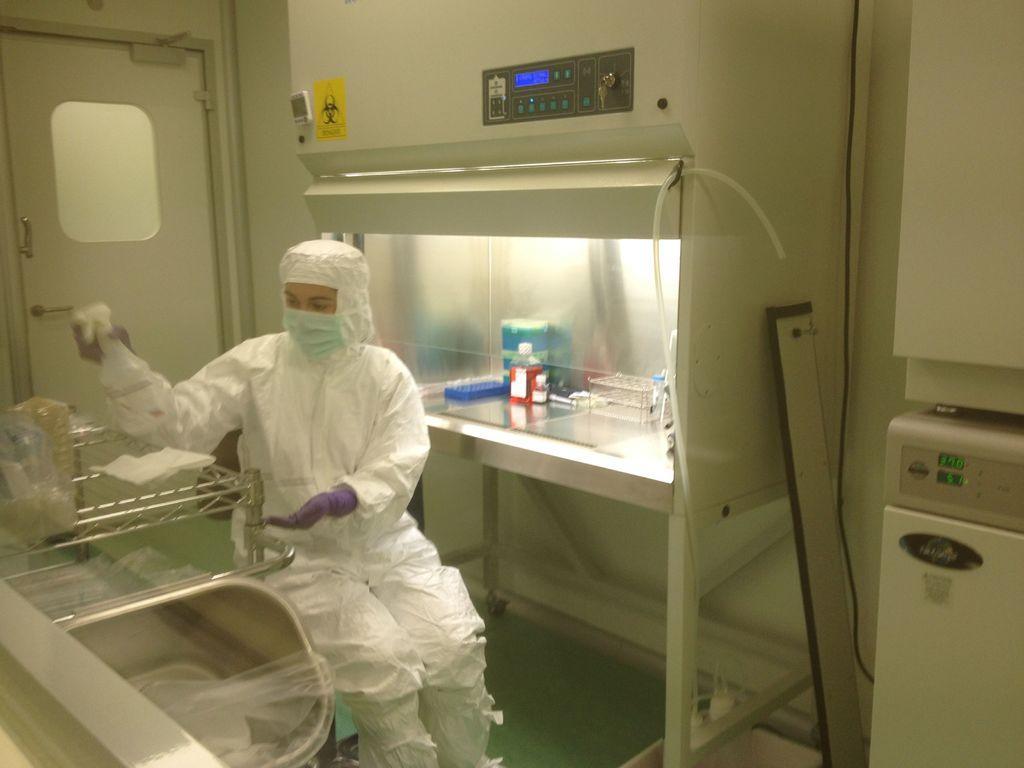Can you describe this image briefly? In this image there is one person who is wearing a mask, and the person is holding some bottle and spraying. In font of the person there are some plastic covers and some other objects, in the background there is table on that table there are some baskets and some other objects. In the background there is door and wall, and on the right side there is one board and in the center there are some boards. At the bottom there is floor. 